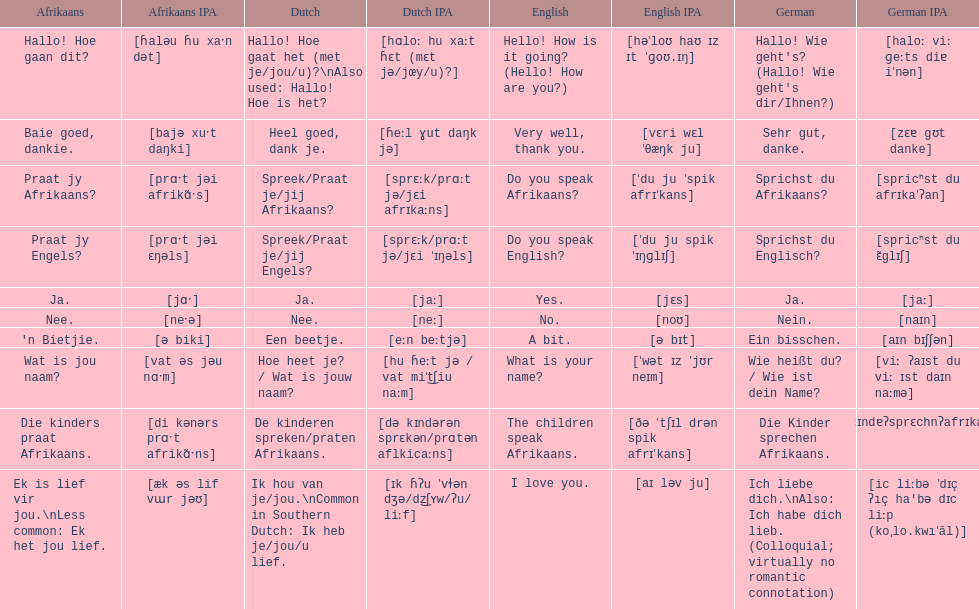How do you say "do you speak afrikaans?" in afrikaans? Praat jy Afrikaans?. 